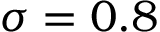Convert formula to latex. <formula><loc_0><loc_0><loc_500><loc_500>\sigma = 0 . 8</formula> 